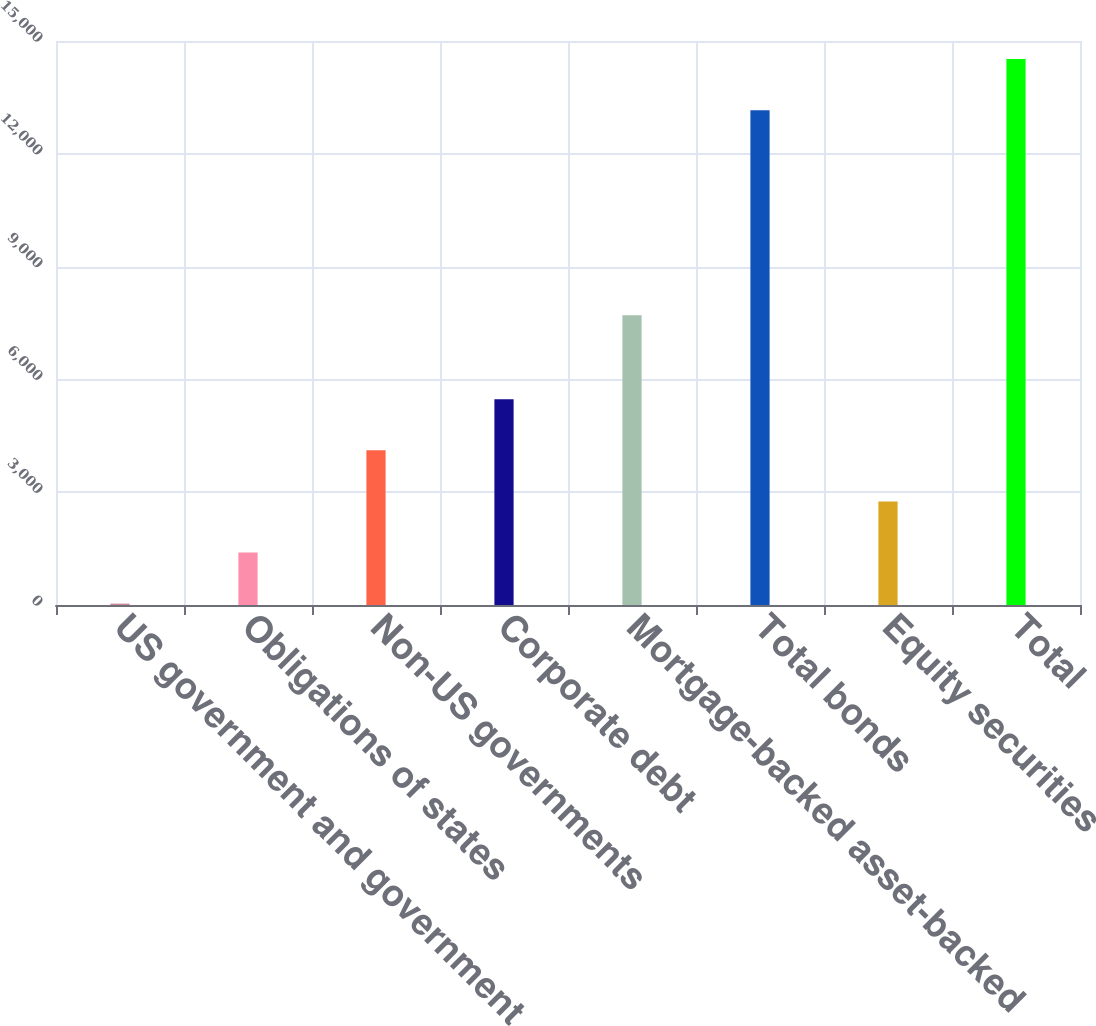<chart> <loc_0><loc_0><loc_500><loc_500><bar_chart><fcel>US government and government<fcel>Obligations of states<fcel>Non-US governments<fcel>Corporate debt<fcel>Mortgage-backed asset-backed<fcel>Total bonds<fcel>Equity securities<fcel>Total<nl><fcel>37<fcel>1395.7<fcel>4113.1<fcel>5471.8<fcel>7703<fcel>13161<fcel>2754.4<fcel>14519.7<nl></chart> 